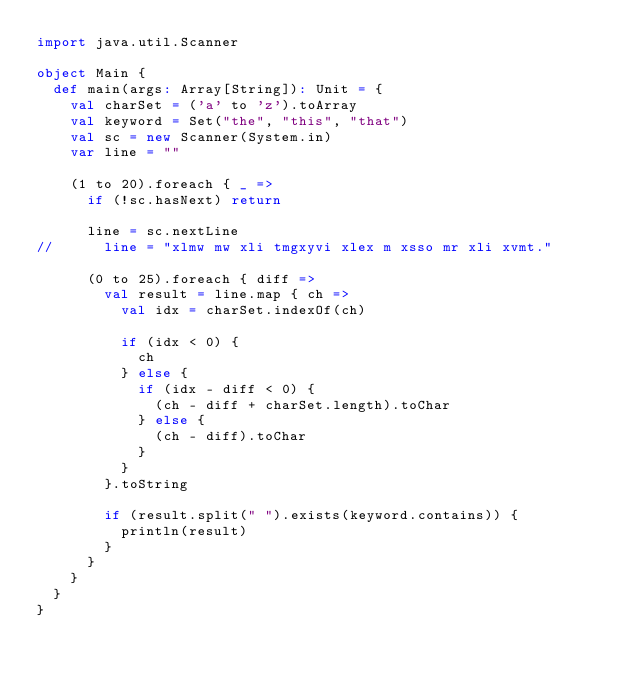<code> <loc_0><loc_0><loc_500><loc_500><_Scala_>import java.util.Scanner

object Main {
  def main(args: Array[String]): Unit = {
    val charSet = ('a' to 'z').toArray
    val keyword = Set("the", "this", "that")
    val sc = new Scanner(System.in)
    var line = ""

    (1 to 20).foreach { _ =>
      if (!sc.hasNext) return

      line = sc.nextLine
//      line = "xlmw mw xli tmgxyvi xlex m xsso mr xli xvmt."

      (0 to 25).foreach { diff =>
        val result = line.map { ch =>
          val idx = charSet.indexOf(ch)

          if (idx < 0) {
            ch
          } else {
            if (idx - diff < 0) {
              (ch - diff + charSet.length).toChar
            } else {
              (ch - diff).toChar
            }
          }
        }.toString

        if (result.split(" ").exists(keyword.contains)) {
          println(result)
        }
      }
    }
  }
}</code> 